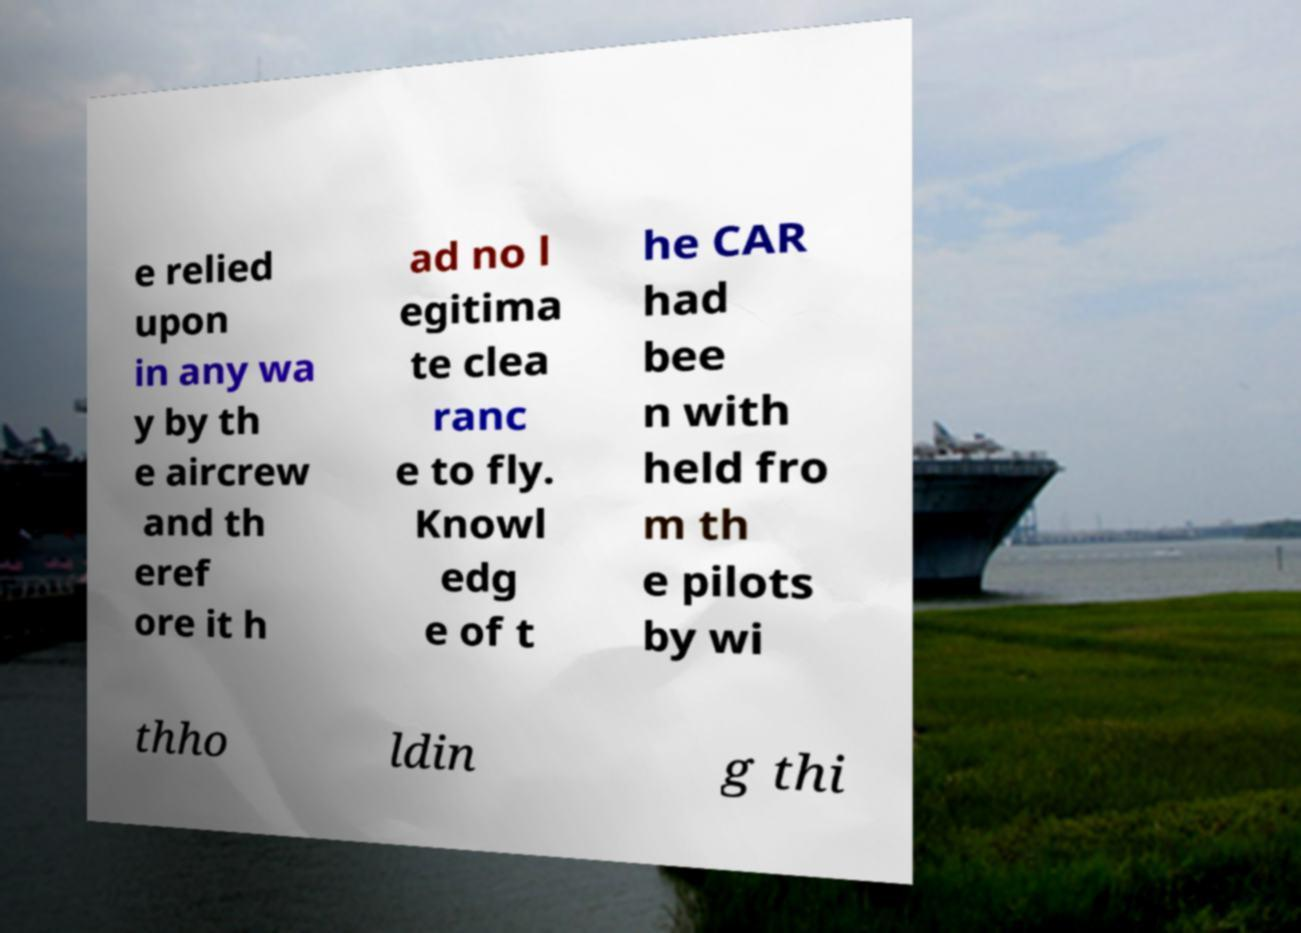Could you extract and type out the text from this image? e relied upon in any wa y by th e aircrew and th eref ore it h ad no l egitima te clea ranc e to fly. Knowl edg e of t he CAR had bee n with held fro m th e pilots by wi thho ldin g thi 